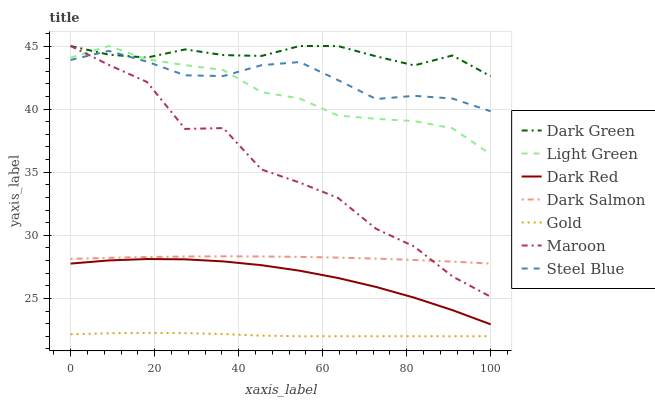Does Gold have the minimum area under the curve?
Answer yes or no. Yes. Does Dark Green have the maximum area under the curve?
Answer yes or no. Yes. Does Dark Red have the minimum area under the curve?
Answer yes or no. No. Does Dark Red have the maximum area under the curve?
Answer yes or no. No. Is Dark Salmon the smoothest?
Answer yes or no. Yes. Is Maroon the roughest?
Answer yes or no. Yes. Is Dark Red the smoothest?
Answer yes or no. No. Is Dark Red the roughest?
Answer yes or no. No. Does Gold have the lowest value?
Answer yes or no. Yes. Does Dark Red have the lowest value?
Answer yes or no. No. Does Dark Green have the highest value?
Answer yes or no. Yes. Does Dark Red have the highest value?
Answer yes or no. No. Is Dark Salmon less than Dark Green?
Answer yes or no. Yes. Is Dark Red greater than Gold?
Answer yes or no. Yes. Does Dark Green intersect Steel Blue?
Answer yes or no. Yes. Is Dark Green less than Steel Blue?
Answer yes or no. No. Is Dark Green greater than Steel Blue?
Answer yes or no. No. Does Dark Salmon intersect Dark Green?
Answer yes or no. No. 